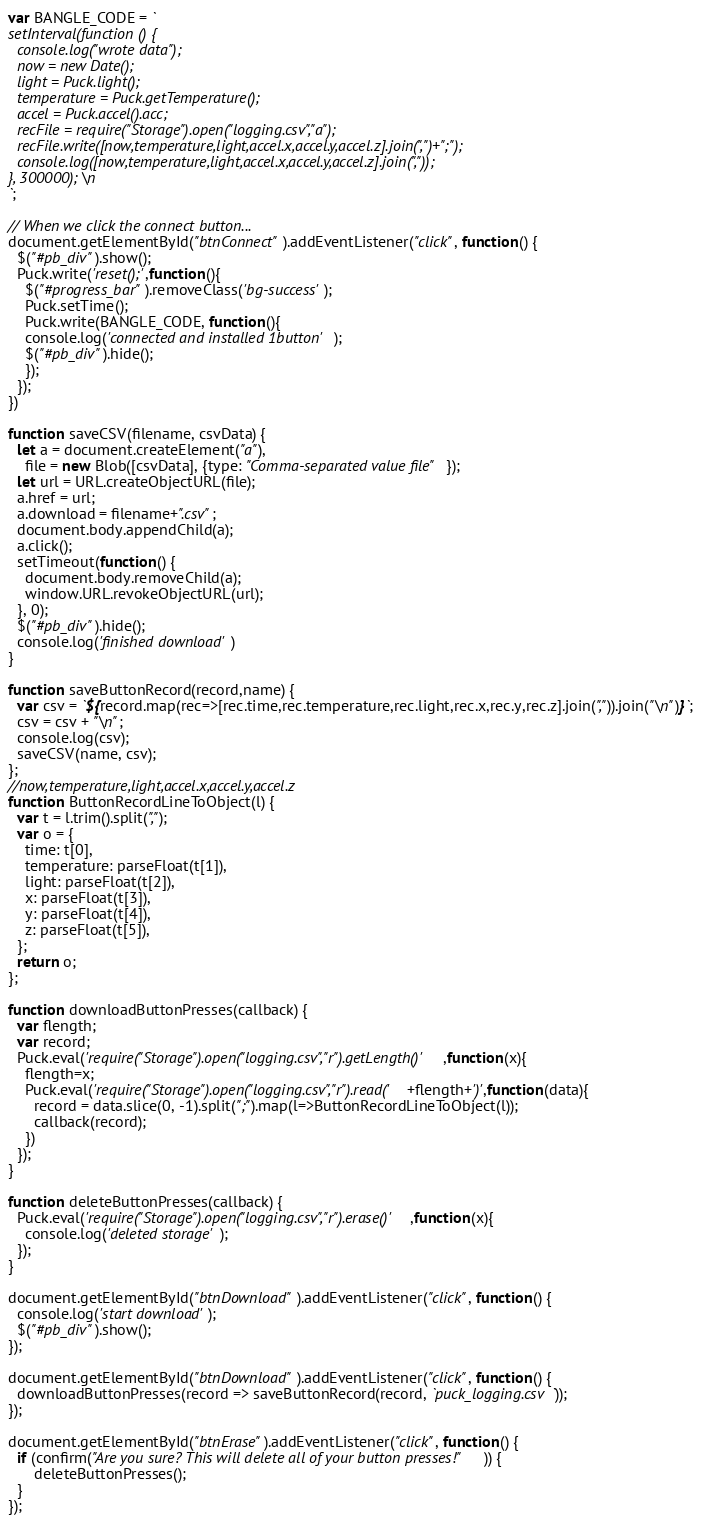Convert code to text. <code><loc_0><loc_0><loc_500><loc_500><_JavaScript_>var BANGLE_CODE = `
setInterval(function () {
  console.log("wrote data");
  now = new Date();
  light = Puck.light();
  temperature = Puck.getTemperature();
  accel = Puck.accel().acc;
  recFile = require("Storage").open("logging.csv","a");
  recFile.write([now,temperature,light,accel.x,accel.y,accel.z].join(",")+";");
  console.log([now,temperature,light,accel.x,accel.y,accel.z].join(","));
}, 300000);\n
`;

// When we click the connect button...
document.getElementById("btnConnect").addEventListener("click", function() {
  $("#pb_div").show();
  Puck.write('reset();',function(){
    $("#progress_bar").removeClass('bg-success');
    Puck.setTime();
    Puck.write(BANGLE_CODE, function(){
    console.log('connected and installed 1button');
    $("#pb_div").hide();
    });
  });
})

function saveCSV(filename, csvData) {
  let a = document.createElement("a"),
    file = new Blob([csvData], {type: "Comma-separated value file"});
  let url = URL.createObjectURL(file);
  a.href = url;
  a.download = filename+".csv";
  document.body.appendChild(a);
  a.click();
  setTimeout(function() {
    document.body.removeChild(a);
    window.URL.revokeObjectURL(url);
  }, 0);
  $("#pb_div").hide();
  console.log('finished download')
}

function saveButtonRecord(record,name) {
  var csv = `${record.map(rec=>[rec.time,rec.temperature,rec.light,rec.x,rec.y,rec.z].join(",")).join("\n")}`;
  csv = csv + "\n";
  console.log(csv);
  saveCSV(name, csv);
};
//now,temperature,light,accel.x,accel.y,accel.z
function ButtonRecordLineToObject(l) {
  var t = l.trim().split(",");
  var o = {
    time: t[0],
    temperature: parseFloat(t[1]),
    light: parseFloat(t[2]),
    x: parseFloat(t[3]),
    y: parseFloat(t[4]),
    z: parseFloat(t[5]),
  };
  return o;
};

function downloadButtonPresses(callback) {
  var flength;
  var record;
  Puck.eval('require("Storage").open("logging.csv","r").getLength()',function(x){
    flength=x;
    Puck.eval('require("Storage").open("logging.csv","r").read('+flength+')',function(data){
      record = data.slice(0, -1).split(";").map(l=>ButtonRecordLineToObject(l));
      callback(record);
    })
  });
}

function deleteButtonPresses(callback) {
  Puck.eval('require("Storage").open("logging.csv","r").erase()',function(x){
    console.log('deleted storage');
  });
}

document.getElementById("btnDownload").addEventListener("click", function() {
  console.log('start download');
  $("#pb_div").show();
});

document.getElementById("btnDownload").addEventListener("click", function() {
  downloadButtonPresses(record => saveButtonRecord(record, `puck_logging.csv`));
});

document.getElementById("btnErase").addEventListener("click", function() {
  if (confirm("Are you sure? This will delete all of your button presses!")) {
      deleteButtonPresses();
  }
});
</code> 